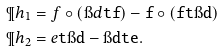<formula> <loc_0><loc_0><loc_500><loc_500>\P h _ { 1 } & = f \circ ( \i d \tt t f ) - f \circ ( f \tt t \i d ) \\ \P h _ { 2 } & = e \tt t \i d - \i d \tt t e .</formula> 